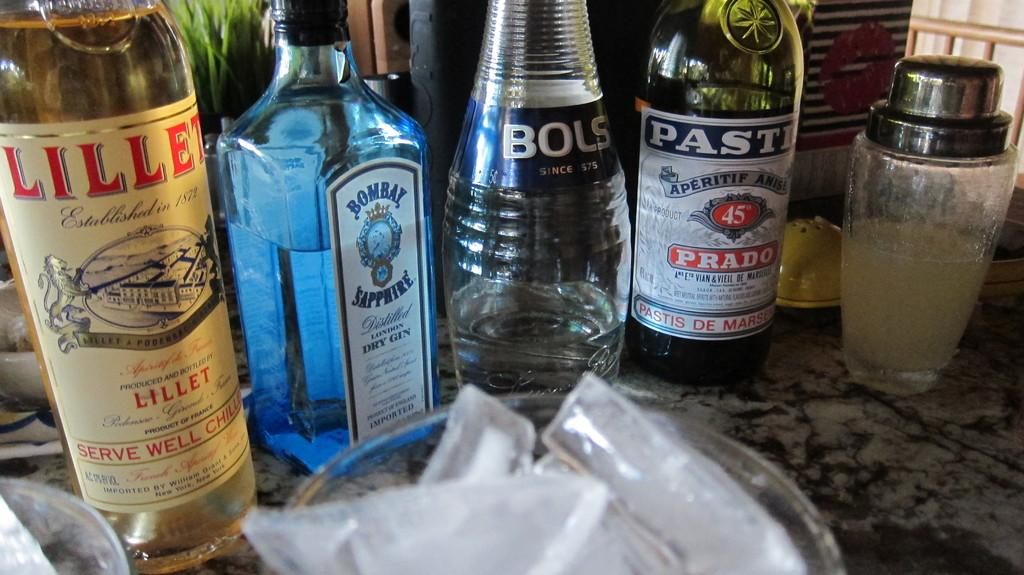<image>
Offer a succinct explanation of the picture presented. A bottle of Bombay Sapphire is among three other bottles of alcohol. 